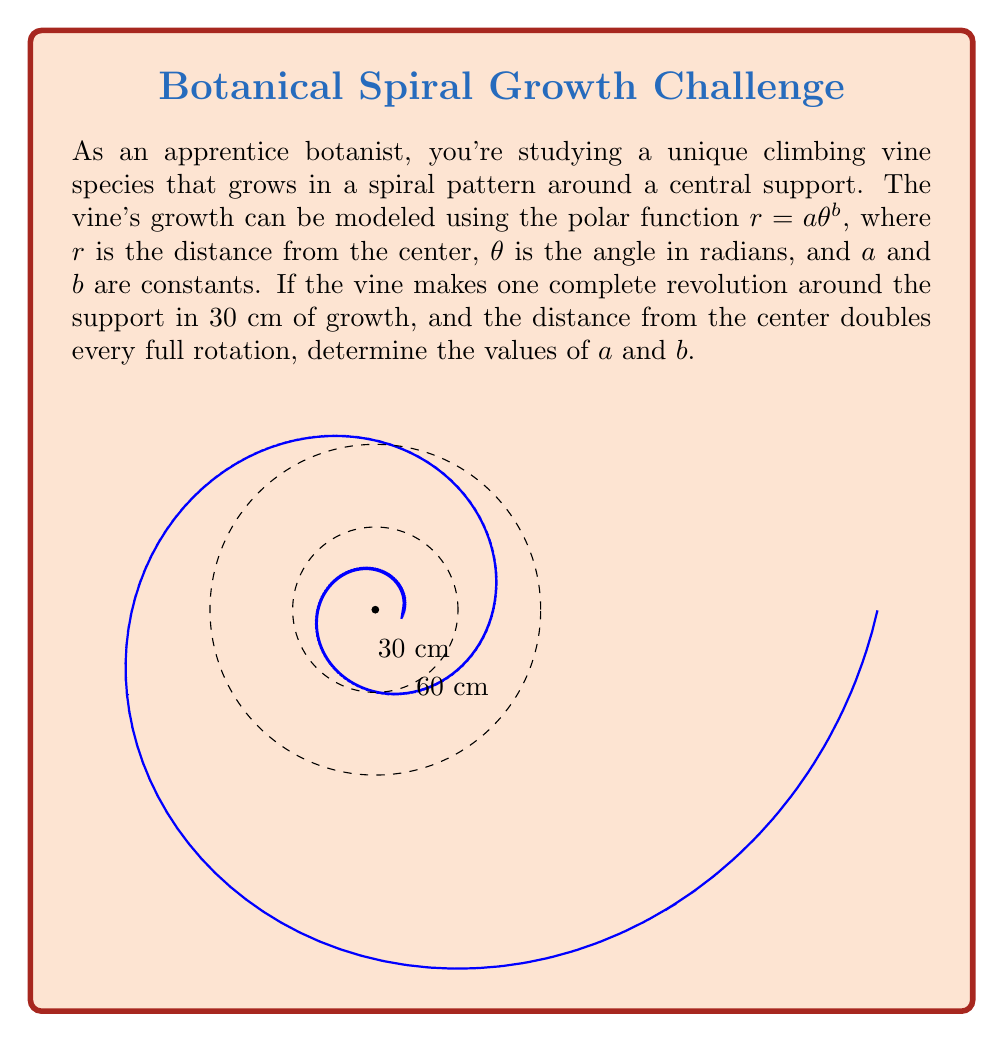Provide a solution to this math problem. Let's approach this step-by-step:

1) We're given that $r = a\theta^b$. We need to find $a$ and $b$.

2) We know that one complete revolution occurs at $\theta = 2\pi$ radians, and the radius doubles every rotation.

3) Let's set up two equations based on this information:
   At $\theta = 2\pi$, $r = 30$
   At $\theta = 4\pi$, $r = 60$

4) Equation 1: $30 = a(2\pi)^b$
   Equation 2: $60 = a(4\pi)^b$

5) Dividing Equation 2 by Equation 1:
   $\frac{60}{30} = \frac{a(4\pi)^b}{a(2\pi)^b}$

6) Simplifying:
   $2 = (\frac{4\pi}{2\pi})^b = 2^b$

7) Taking the logarithm of both sides:
   $\log 2 = b \log 2$

8) Therefore, $b = 1$

9) Now we can substitute this back into Equation 1:
   $30 = a(2\pi)^1$

10) Solving for $a$:
    $a = \frac{30}{2\pi} \approx 4.77$

Thus, we have found both $a$ and $b$.
Answer: $a \approx 4.77$, $b = 1$ 